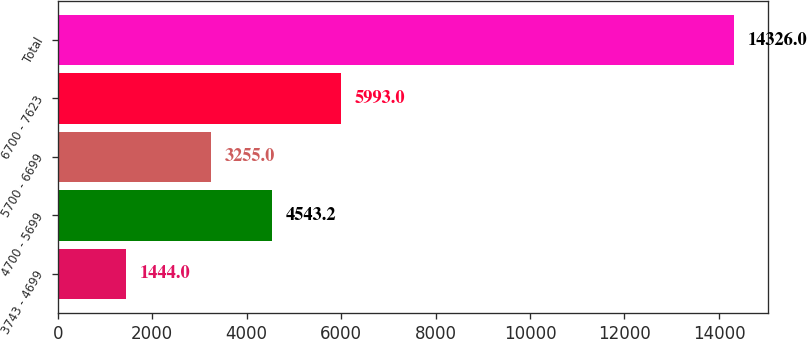Convert chart. <chart><loc_0><loc_0><loc_500><loc_500><bar_chart><fcel>3743 - 4699<fcel>4700 - 5699<fcel>5700 - 6699<fcel>6700 - 7623<fcel>Total<nl><fcel>1444<fcel>4543.2<fcel>3255<fcel>5993<fcel>14326<nl></chart> 